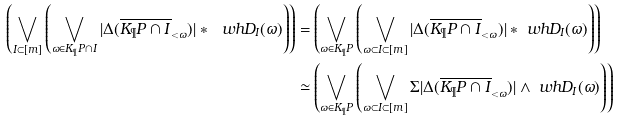<formula> <loc_0><loc_0><loc_500><loc_500>\left ( \bigvee _ { I \subset [ m ] } \left ( \bigvee _ { \omega \in K _ { \P } P \cap I } | \Delta ( \overline { K _ { \P } P \cap I } _ { < \omega } ) | \ast \ w h { D } _ { I } ( \omega ) \right ) \right ) = & \left ( \bigvee _ { \omega \in K _ { \P } P } \left ( \bigvee _ { \omega \subset I \subset [ m ] } | \Delta ( \overline { K _ { \P } P \cap I } _ { < \omega } ) | \ast \ w h { D } _ { I } ( \omega ) \right ) \right ) \\ \simeq & \left ( \bigvee _ { \omega \in K _ { \P } P } \left ( \bigvee _ { \omega \subset I \subset [ m ] } \Sigma | \Delta ( \overline { K _ { \P } P \cap I } _ { < \omega } ) | \wedge \ w h { D } _ { I } ( \omega ) \right ) \right )</formula> 